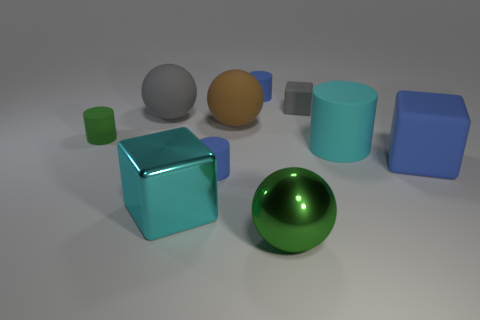There is a cyan object that is behind the big blue matte block; does it have the same shape as the large brown thing on the right side of the small green thing? The cyan object behind the large blue block is actually a cube, which differs in shape from the large brown cuboid situated on the right of the small green cube. While both have some rectangular faces, the cyan cube has equal dimensions on all sides, making it a regular polyhedron, whereas the brown object has a stretched form, making it a cuboid. 